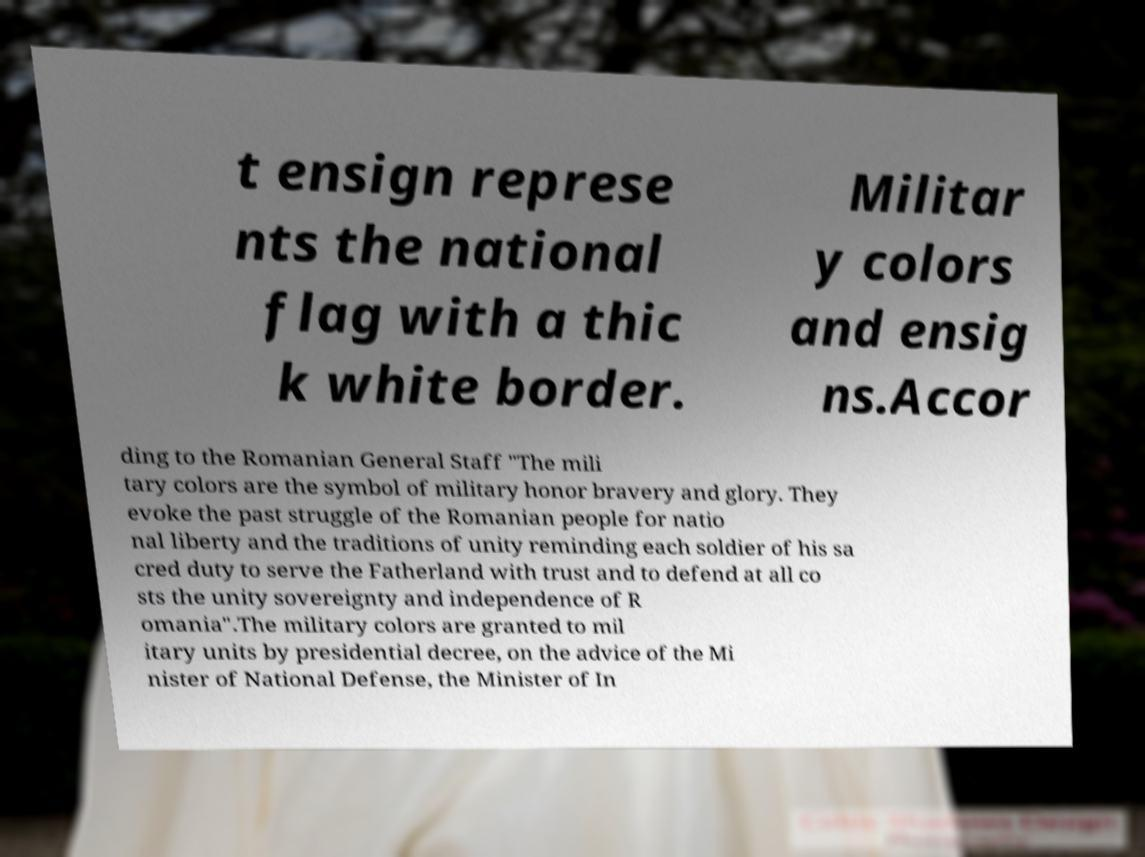Could you extract and type out the text from this image? t ensign represe nts the national flag with a thic k white border. Militar y colors and ensig ns.Accor ding to the Romanian General Staff "The mili tary colors are the symbol of military honor bravery and glory. They evoke the past struggle of the Romanian people for natio nal liberty and the traditions of unity reminding each soldier of his sa cred duty to serve the Fatherland with trust and to defend at all co sts the unity sovereignty and independence of R omania".The military colors are granted to mil itary units by presidential decree, on the advice of the Mi nister of National Defense, the Minister of In 